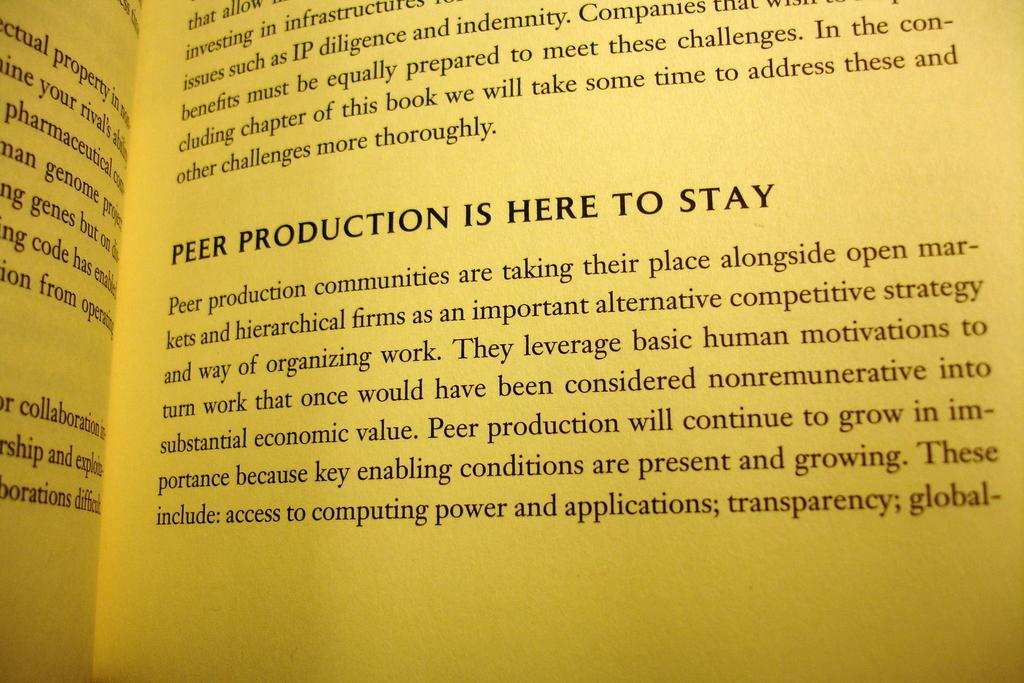What is present in the image that can be written or read on? There are papers in the image. What can be found on the papers in the image? The papers have printed text on them. How many snails can be seen crawling on the papers in the image? There are no snails present in the image; it only features papers with printed text. What shape is the voice in the image? There is no voice present in the image, as voices are audible and cannot be seen. 